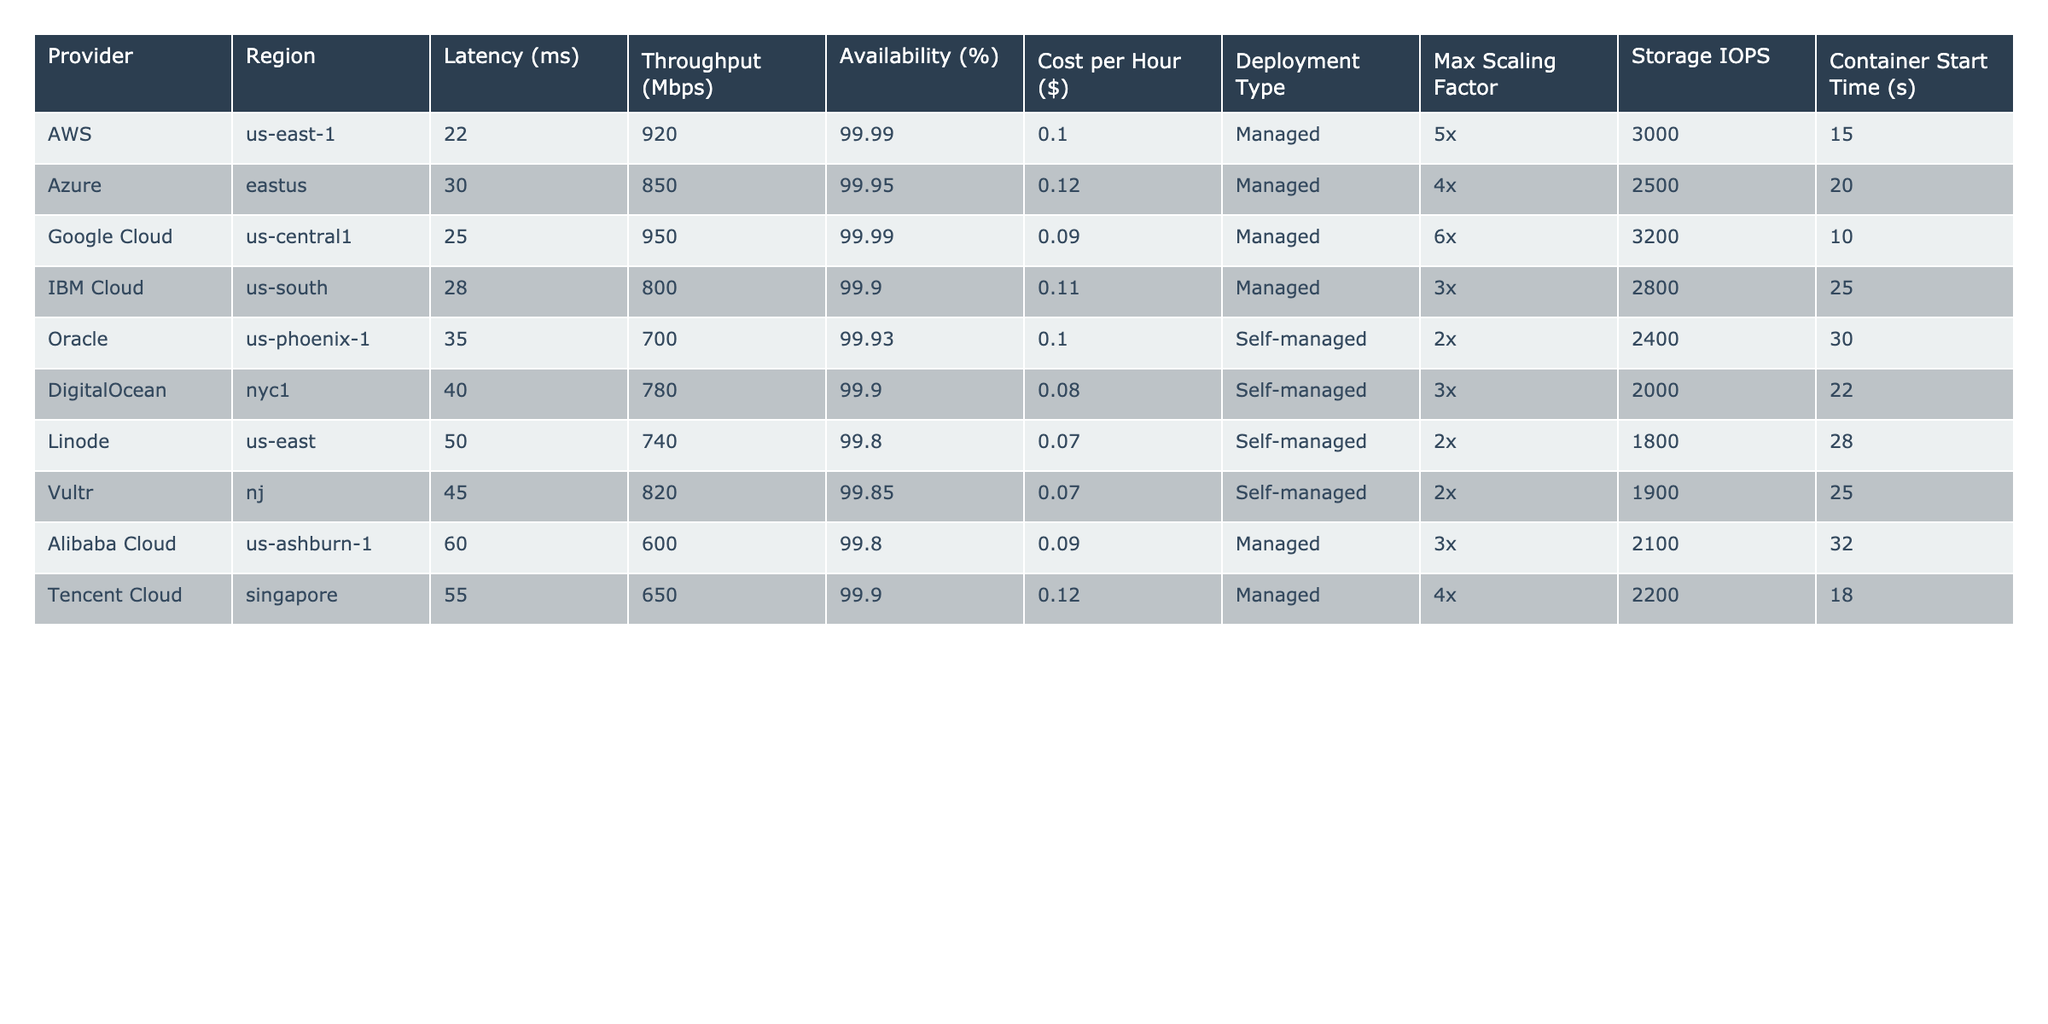What is the latency for Google Cloud in us-central1? The table shows the value for Latency (ms) under the Provider "Google Cloud" and Region "us-central1," which is 25 ms.
Answer: 25 ms Which provider has the highest availability percentage? Comparing the Availability (%) values across all providers, AWS and Google Cloud both have the highest value of 99.99%.
Answer: AWS and Google Cloud What is the average cost per hour across all providers? The cost values are 0.10, 0.12, 0.09, 0.11, 0.10, 0.08, 0.07, 0.07, 0.09, and 0.12, summing these gives 1.05. There are 10 providers, so 1.05 / 10 = 0.105 is the average cost per hour.
Answer: 0.105 Which provider has the lowest throughput? Looking at the Throughput (Mbps) column, the lowest value is 600 Mbps from Alibaba Cloud.
Answer: Alibaba Cloud Is the container start time for DigitalOcean less than that of Azure? DigitalOcean's Container Start Time is 22 seconds, while Azure's is 20 seconds, meaning DigitalOcean's time is greater than Azure's. Therefore, the statement is false.
Answer: False What is the total latency for all providers? The individual latencies are summed up: 22 + 30 + 25 + 28 + 35 + 40 + 50 + 45 + 60 + 55 = 390 ms for all providers.
Answer: 390 ms If you compare the maximum scaling factor between managed and self-managed types, which one has the higher maximum scaling factor? Analyzing the deployments, the maximum scaling factors for managed types (5x, 4x, 6x, 3x, 3x, 4x) have a maximum of 6x, while self-managed (2x, 3x, 2x, 2x) have a maximum of 3x. Therefore, managed has a higher scaling factor.
Answer: Managed types Which regions have an availability of 99.90% or higher? From the Availability (%) column, the regions with 99.90% or higher are: us-east-1 (99.99%), eastus (99.95%), us-central1 (99.99%), us-south (99.90%), nj (99.85%), and others fall below this threshold.
Answer: 6 regions What is the difference in cost per hour between the cheapest and the most expensive providers? The cheapest provider is DigitalOcean at $0.08 per hour, and the most expensive one is Azure at $0.12 per hour. The difference is $0.12 - $0.08 = $0.04.
Answer: $0.04 Which provider in the US regions has the fastest latency? The latency values show that AWS in us-east-1 has the fastest latency at 22 ms among all US regions.
Answer: AWS in us-east-1 